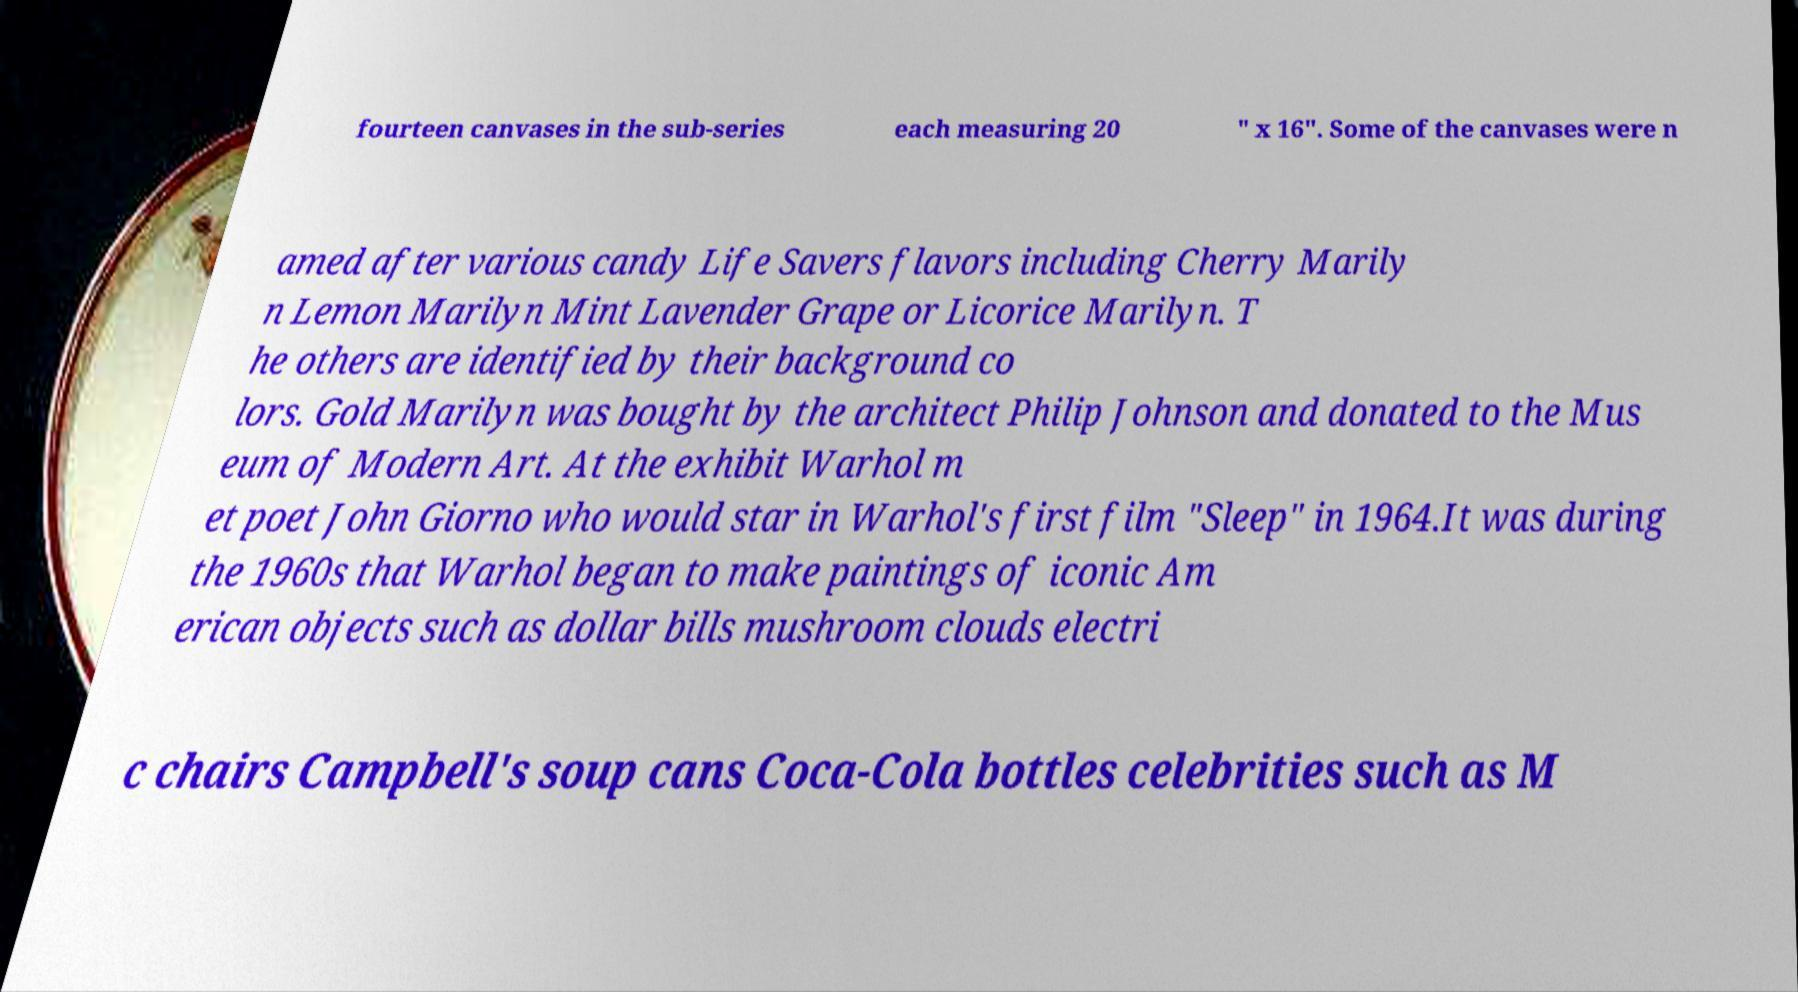Could you extract and type out the text from this image? fourteen canvases in the sub-series each measuring 20 ″ x 16″. Some of the canvases were n amed after various candy Life Savers flavors including Cherry Marily n Lemon Marilyn Mint Lavender Grape or Licorice Marilyn. T he others are identified by their background co lors. Gold Marilyn was bought by the architect Philip Johnson and donated to the Mus eum of Modern Art. At the exhibit Warhol m et poet John Giorno who would star in Warhol's first film "Sleep" in 1964.It was during the 1960s that Warhol began to make paintings of iconic Am erican objects such as dollar bills mushroom clouds electri c chairs Campbell's soup cans Coca-Cola bottles celebrities such as M 